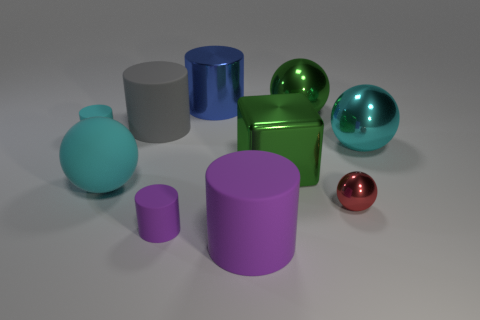Subtract all yellow cylinders. How many cyan balls are left? 2 Subtract all big rubber cylinders. How many cylinders are left? 3 Subtract all green spheres. How many spheres are left? 3 Subtract 2 balls. How many balls are left? 2 Subtract all cubes. How many objects are left? 9 Subtract 0 green cylinders. How many objects are left? 10 Subtract all cyan cubes. Subtract all blue cylinders. How many cubes are left? 1 Subtract all small red things. Subtract all big gray rubber things. How many objects are left? 8 Add 4 large blue cylinders. How many large blue cylinders are left? 5 Add 3 green blocks. How many green blocks exist? 4 